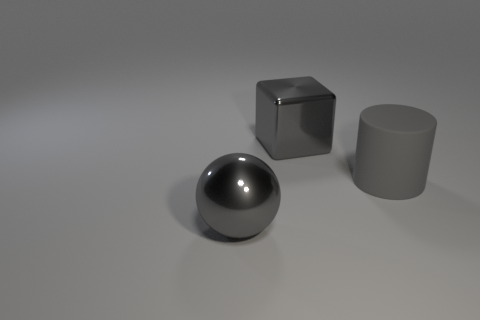Is there anything else that is the same material as the gray cylinder?
Ensure brevity in your answer.  No. Are the big ball and the object that is right of the metallic cube made of the same material?
Offer a very short reply. No. What is the material of the gray cube?
Your response must be concise. Metal. What material is the ball that is left of the big gray metal object that is behind the thing to the left of the gray cube?
Ensure brevity in your answer.  Metal. There is a gray thing on the right side of the big gray metal block; does it have the same size as the gray object that is behind the big gray matte cylinder?
Offer a very short reply. Yes. What number of other things are there of the same material as the gray sphere
Provide a short and direct response. 1. How many matte things are gray spheres or large red cubes?
Your answer should be very brief. 0. Is the number of large shiny blocks less than the number of purple rubber cylinders?
Your response must be concise. No. There is a gray block; is its size the same as the thing that is in front of the large rubber cylinder?
Offer a very short reply. Yes. Is there anything else that is the same shape as the gray rubber object?
Offer a terse response. No. 